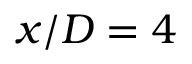Convert formula to latex. <formula><loc_0><loc_0><loc_500><loc_500>x / D = 4</formula> 